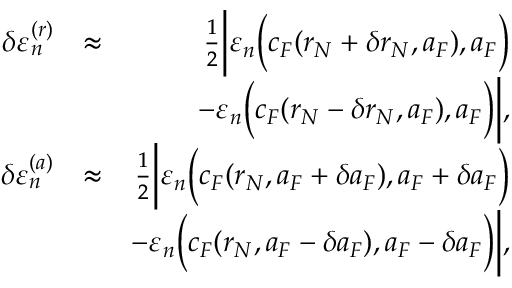<formula> <loc_0><loc_0><loc_500><loc_500>\begin{array} { r l r } { \delta \varepsilon _ { n } ^ { ( r ) } } & { \approx } & { \frac { 1 } { 2 } \left | \varepsilon _ { n } \left ( c _ { F } ( r _ { N } + \delta r _ { N } , a _ { F } ) , a _ { F } \right ) } \\ & { - \varepsilon _ { n } \left ( c _ { F } ( r _ { N } - \delta r _ { N } , a _ { F } ) , a _ { F } \right ) \right | , } \\ { \delta \varepsilon _ { n } ^ { ( a ) } } & { \approx } & { \frac { 1 } { 2 } \left | \varepsilon _ { n } \left ( c _ { F } ( r _ { N } , a _ { F } + \delta a _ { F } ) , a _ { F } + \delta a _ { F } \right ) } \\ & { - \varepsilon _ { n } \left ( c _ { F } ( r _ { N } , a _ { F } - \delta a _ { F } ) , a _ { F } - \delta a _ { F } \right ) \right | , } \end{array}</formula> 